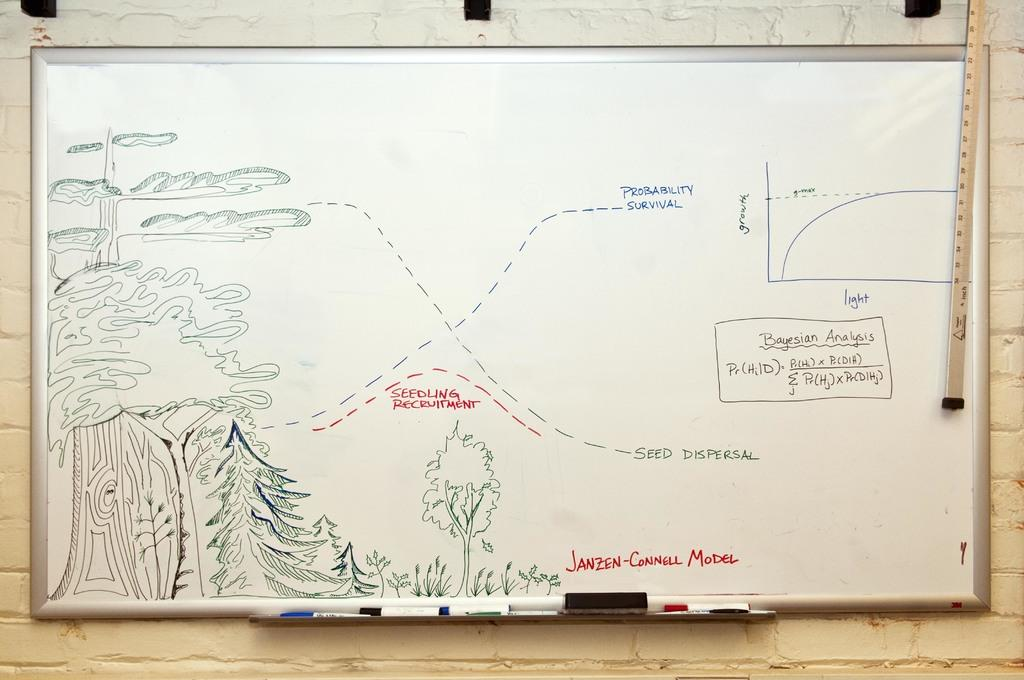<image>
Write a terse but informative summary of the picture. Seedling recruitment is an area in the middle of the map 